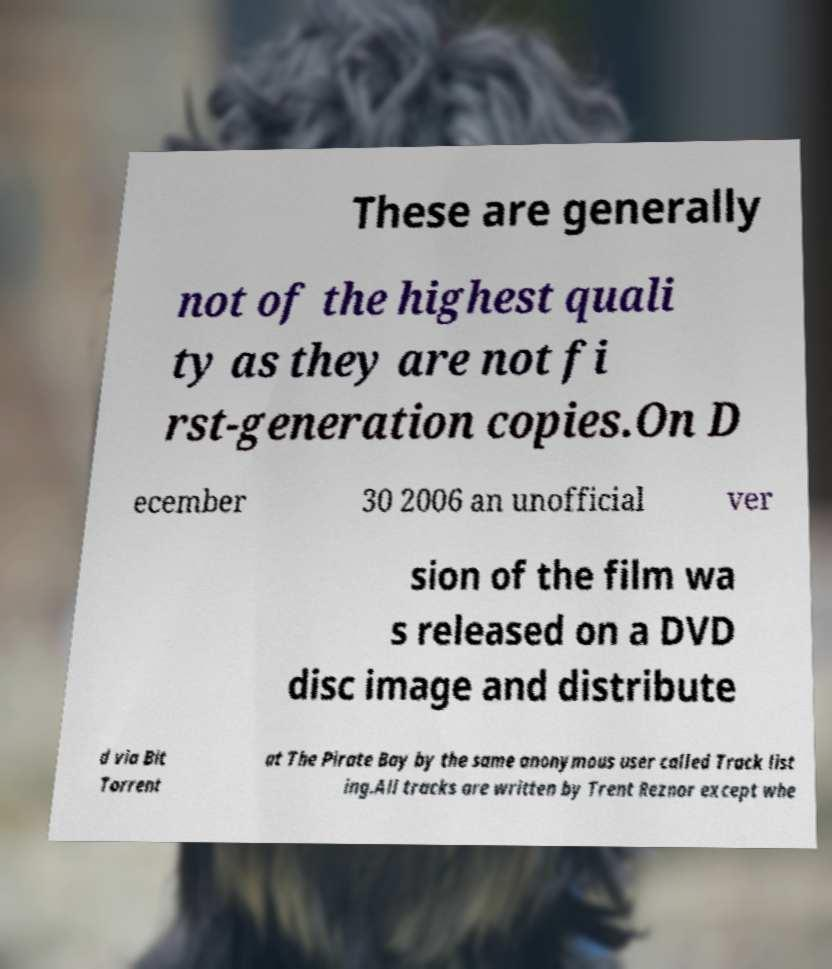Could you extract and type out the text from this image? These are generally not of the highest quali ty as they are not fi rst-generation copies.On D ecember 30 2006 an unofficial ver sion of the film wa s released on a DVD disc image and distribute d via Bit Torrent at The Pirate Bay by the same anonymous user called Track list ing.All tracks are written by Trent Reznor except whe 